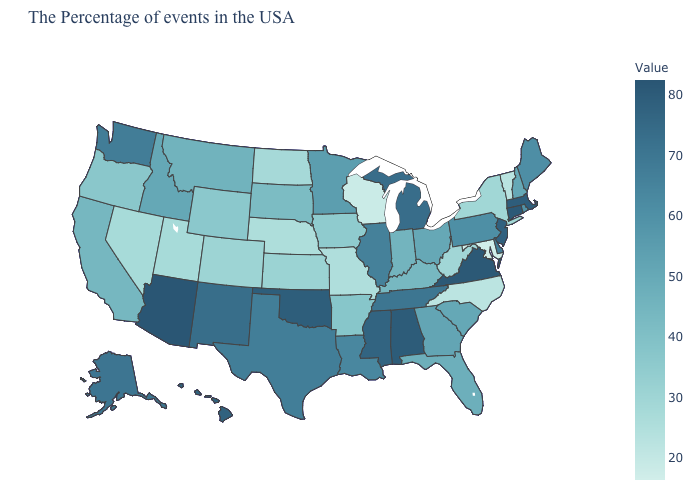Does New Hampshire have the highest value in the Northeast?
Write a very short answer. No. Among the states that border Rhode Island , which have the lowest value?
Keep it brief. Massachusetts. Does the map have missing data?
Keep it brief. No. Does Maryland have the lowest value in the USA?
Concise answer only. Yes. Which states have the lowest value in the West?
Keep it brief. Utah, Nevada. Among the states that border Kentucky , does Virginia have the highest value?
Quick response, please. Yes. Among the states that border Colorado , which have the lowest value?
Short answer required. Nebraska. 